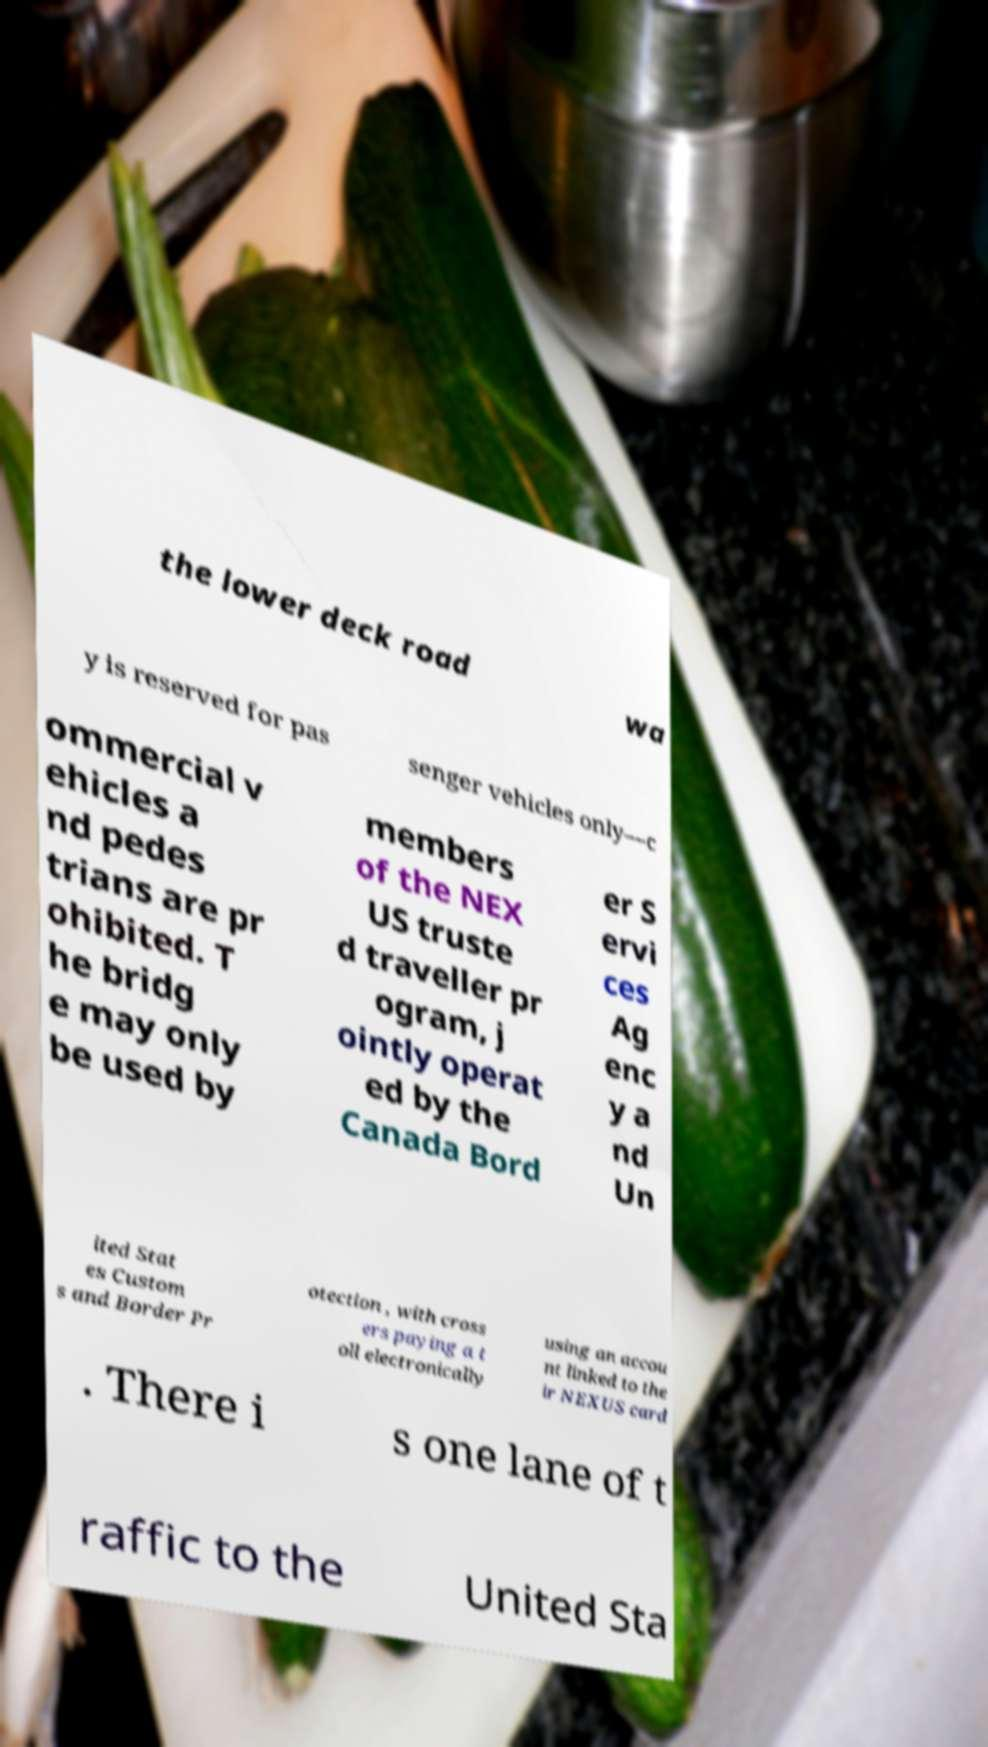There's text embedded in this image that I need extracted. Can you transcribe it verbatim? the lower deck road wa y is reserved for pas senger vehicles only—c ommercial v ehicles a nd pedes trians are pr ohibited. T he bridg e may only be used by members of the NEX US truste d traveller pr ogram, j ointly operat ed by the Canada Bord er S ervi ces Ag enc y a nd Un ited Stat es Custom s and Border Pr otection , with cross ers paying a t oll electronically using an accou nt linked to the ir NEXUS card . There i s one lane of t raffic to the United Sta 